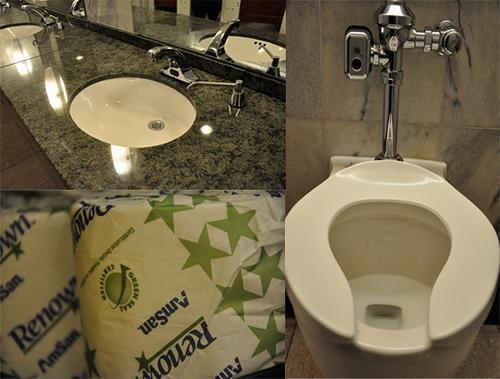How many toilets are shown?
Give a very brief answer. 1. How many rolls of toilet paper?
Give a very brief answer. 2. How many sinks?
Give a very brief answer. 2. 